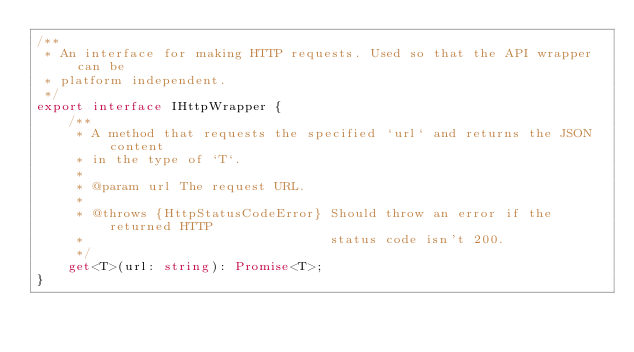Convert code to text. <code><loc_0><loc_0><loc_500><loc_500><_TypeScript_>/**
 * An interface for making HTTP requests. Used so that the API wrapper can be
 * platform independent.
 */
export interface IHttpWrapper {
	/**
	 * A method that requests the specified `url` and returns the JSON content
	 * in the type of `T`.
	 *
	 * @param url The request URL.
	 *
	 * @throws {HttpStatusCodeError} Should throw an error if the returned HTTP
	 *                               status code isn't 200.
	 */
	get<T>(url: string): Promise<T>;
}</code> 